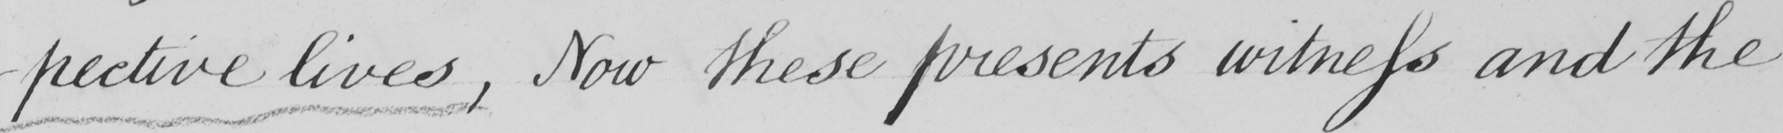What is written in this line of handwriting? -pective lives  , Now these presents witness and the 